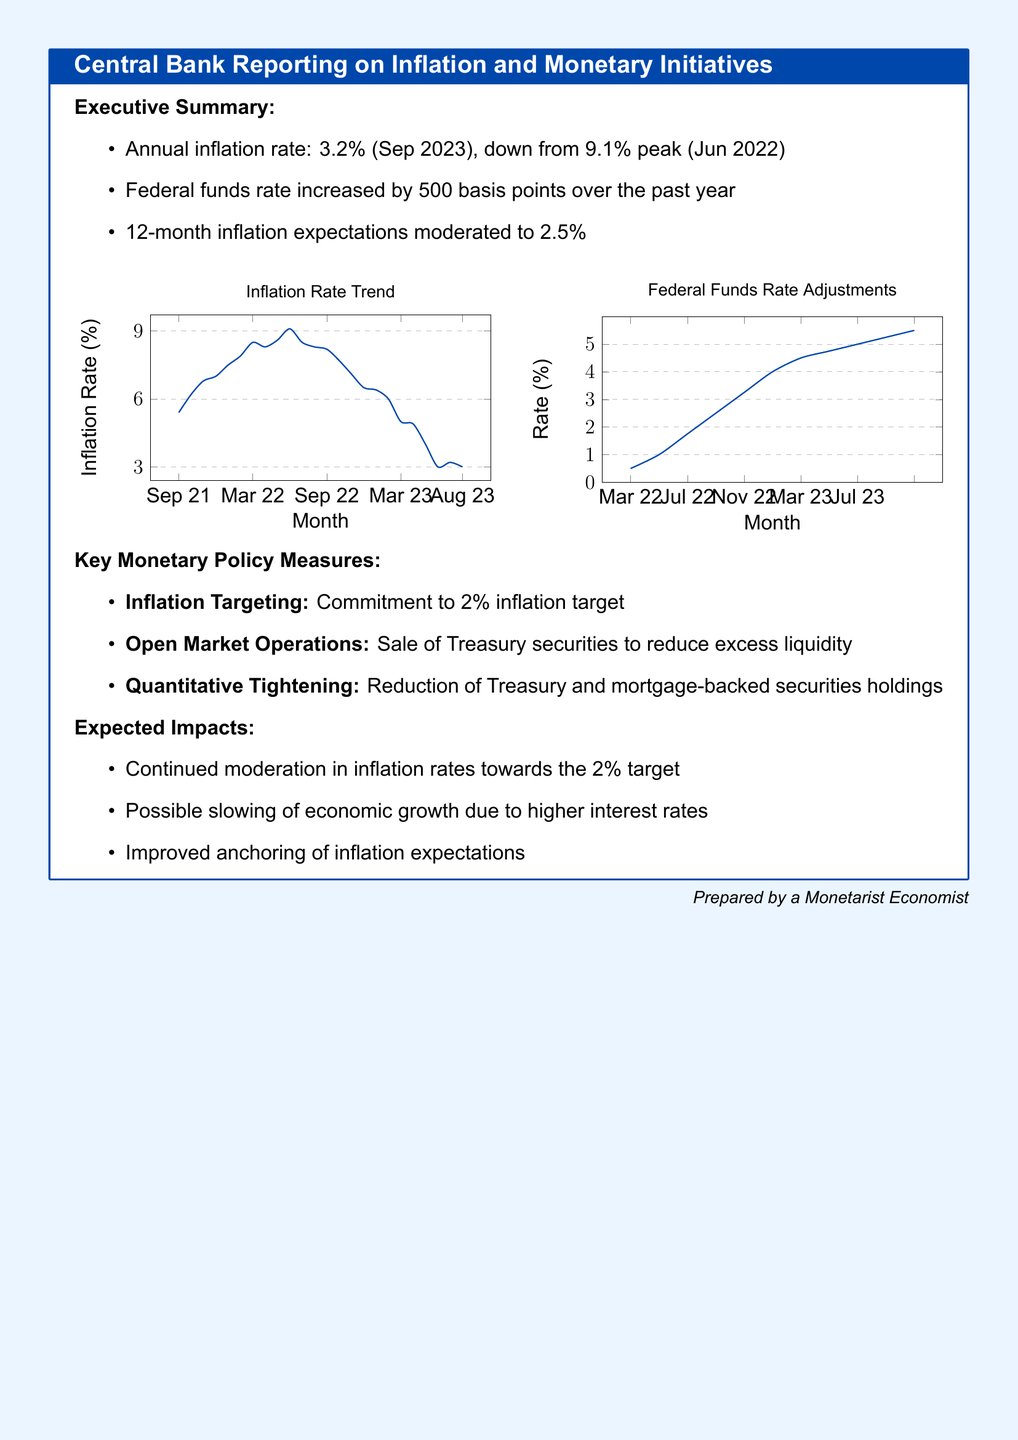what is the current annual inflation rate? The document states that the annual inflation rate as of September 2023 is 3.2%.
Answer: 3.2% what was the peak inflation rate? The document mentions that the peak inflation rate was 9.1% in June 2022.
Answer: 9.1% how many basis points has the federal funds rate been increased? According to the document, the federal funds rate increased by 500 basis points over the past year.
Answer: 500 what is the inflation target set by the central bank? The key monetary policy measure indicates a commitment to a 2% inflation target.
Answer: 2% what are the expected impacts of the monetary policies? The document lists several expected impacts, including continued moderation in inflation rates towards the 2% target.
Answer: Continued moderation in inflation rates towards the 2% target what is the title of the document? The title of the document is highlighted in the tcolorbox, which is "Central Bank Reporting on Inflation and Monetary Initiatives."
Answer: Central Bank Reporting on Inflation and Monetary Initiatives what kind of operations is the central bank conducting to control liquidity? The document mentions that the central bank is involved in the sale of Treasury securities.
Answer: Sale of Treasury securities how long does the 12-month inflation expectation indicate? The document states that the 12-month inflation expectations have moderated to 2.5%.
Answer: 2.5% what is the primary focus of this document? The primary focus is the analysis and reporting on inflation and monetary policy measures.
Answer: Inflation and monetary policy measures 